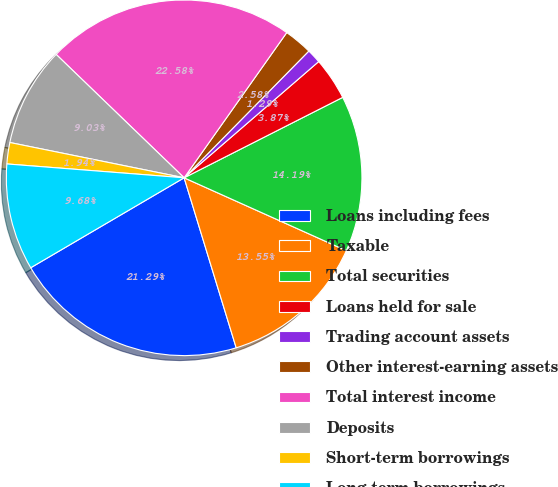<chart> <loc_0><loc_0><loc_500><loc_500><pie_chart><fcel>Loans including fees<fcel>Taxable<fcel>Total securities<fcel>Loans held for sale<fcel>Trading account assets<fcel>Other interest-earning assets<fcel>Total interest income<fcel>Deposits<fcel>Short-term borrowings<fcel>Long-term borrowings<nl><fcel>21.29%<fcel>13.55%<fcel>14.19%<fcel>3.87%<fcel>1.29%<fcel>2.58%<fcel>22.58%<fcel>9.03%<fcel>1.94%<fcel>9.68%<nl></chart> 